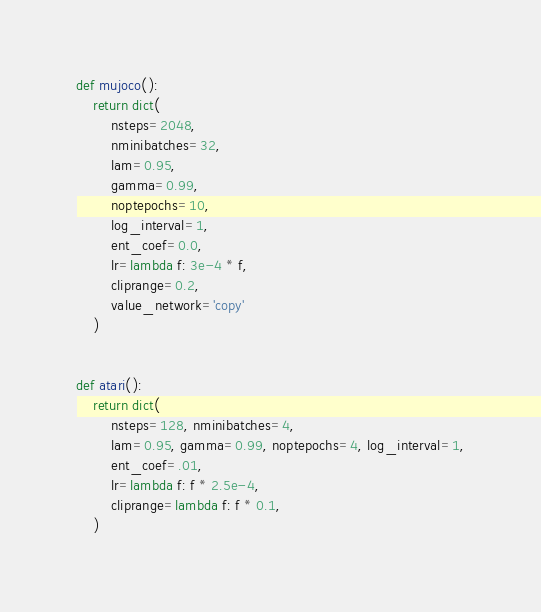<code> <loc_0><loc_0><loc_500><loc_500><_Python_>def mujoco():
    return dict(
        nsteps=2048,
        nminibatches=32,
        lam=0.95,
        gamma=0.99,
        noptepochs=10,
        log_interval=1,
        ent_coef=0.0,
        lr=lambda f: 3e-4 * f,
        cliprange=0.2,
        value_network='copy'
    )


def atari():
    return dict(
        nsteps=128, nminibatches=4,
        lam=0.95, gamma=0.99, noptepochs=4, log_interval=1,
        ent_coef=.01,
        lr=lambda f: f * 2.5e-4,
        cliprange=lambda f: f * 0.1,
    )
</code> 